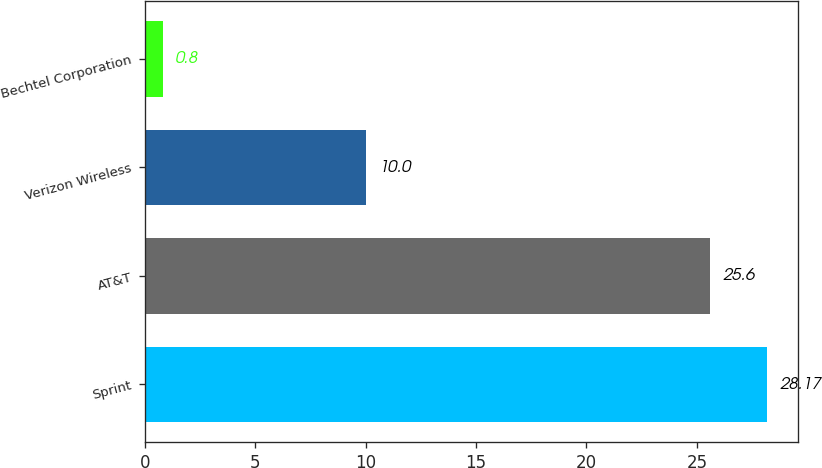<chart> <loc_0><loc_0><loc_500><loc_500><bar_chart><fcel>Sprint<fcel>AT&T<fcel>Verizon Wireless<fcel>Bechtel Corporation<nl><fcel>28.17<fcel>25.6<fcel>10<fcel>0.8<nl></chart> 